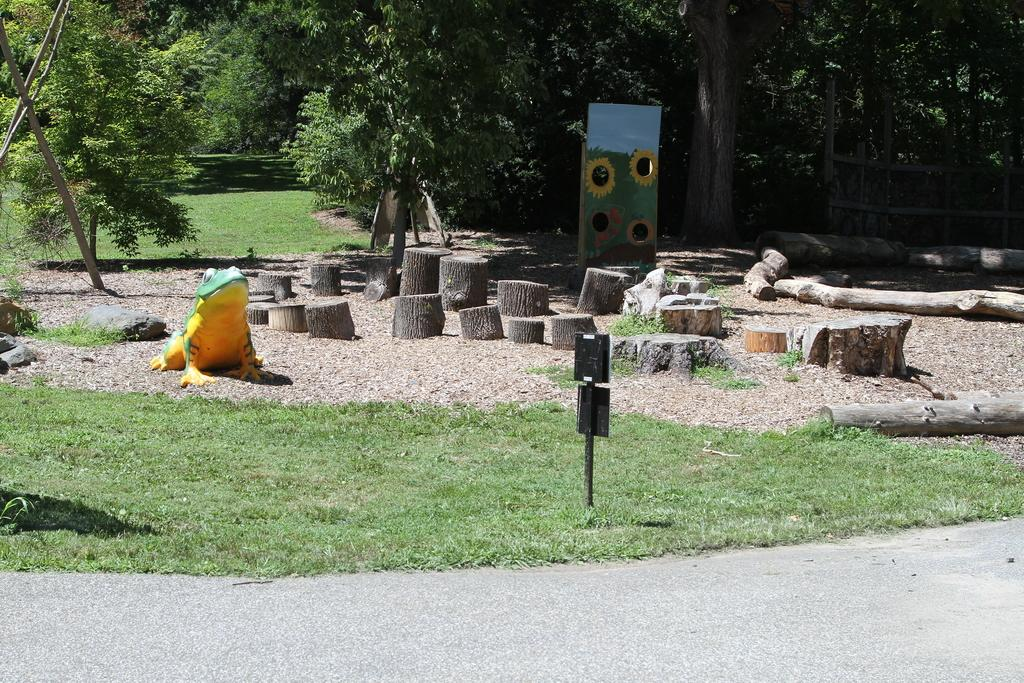What type of vegetation is present in the image? There are trees and grass in the image. What else can be seen in the image besides vegetation? There are branches, boards, a frog, and a road in the image. Can you describe the branches in the image? The branches are likely part of the trees in the image. What might be used for walking or driving on in the image? There is a road in the image for walking or driving on. What is the unspecified object in the image? The unspecified object in the image is not described in the provided facts. Where is the stove located in the image? There is no stove present in the image. What type of face can be seen on the frog in the image? The provided facts do not mention a face on the frog, and there is no indication of a face in the image. 